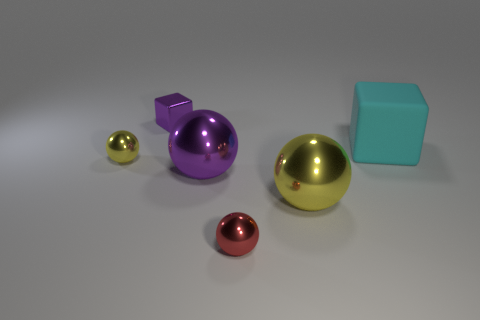How big is the yellow thing left of the big yellow ball to the left of the cube in front of the purple block?
Your response must be concise. Small. There is a ball that is the same color as the tiny block; what is its material?
Give a very brief answer. Metal. How many shiny things are either purple objects or cyan spheres?
Offer a terse response. 2. What size is the cyan rubber thing?
Give a very brief answer. Large. What number of objects are red metal cubes or metallic spheres in front of the big yellow metal ball?
Ensure brevity in your answer.  1. How many other things are the same color as the matte cube?
Make the answer very short. 0. There is a red metallic thing; is it the same size as the yellow metal object that is in front of the tiny yellow object?
Ensure brevity in your answer.  No. There is a yellow metallic thing to the right of the red ball; does it have the same size as the large cube?
Your answer should be compact. Yes. How many other things are made of the same material as the cyan block?
Keep it short and to the point. 0. Are there an equal number of cubes in front of the big yellow metal thing and tiny purple shiny things in front of the cyan rubber object?
Provide a succinct answer. Yes. 